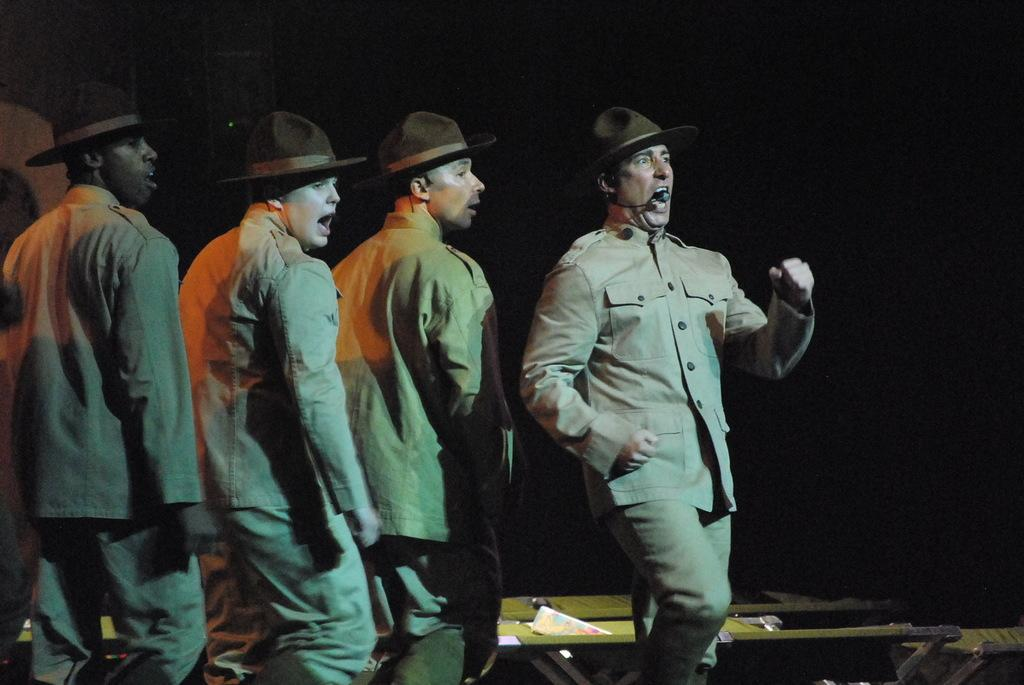Who is present in the image? There are people in the image. What are the people wearing? The people are wearing hats. Can you describe the action of one of the people in the image? There is a person walking on the right side of the image, and they are singing. What can be seen behind the person? There are objects visible behind the person. What type of road can be seen in the image? There is no road visible in the image. How many people are present in the group in the image? The image does not depict a group of people; it only shows individuals. What type of station is present in the image? There is no station visible in the image. 